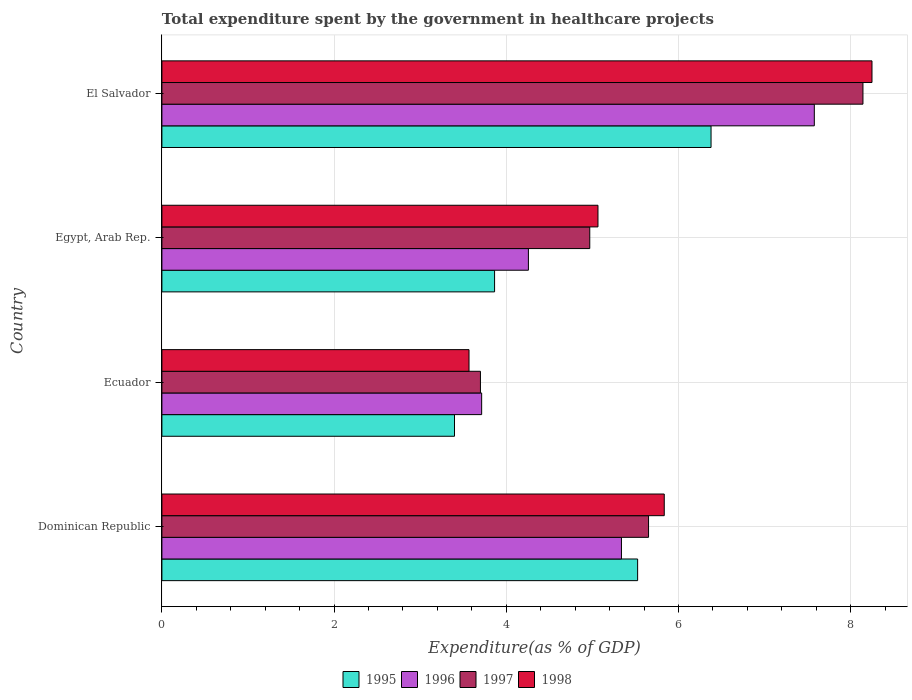How many bars are there on the 4th tick from the top?
Your answer should be very brief. 4. How many bars are there on the 4th tick from the bottom?
Ensure brevity in your answer.  4. What is the label of the 4th group of bars from the top?
Offer a very short reply. Dominican Republic. What is the total expenditure spent by the government in healthcare projects in 1995 in El Salvador?
Make the answer very short. 6.38. Across all countries, what is the maximum total expenditure spent by the government in healthcare projects in 1998?
Make the answer very short. 8.25. Across all countries, what is the minimum total expenditure spent by the government in healthcare projects in 1995?
Provide a succinct answer. 3.4. In which country was the total expenditure spent by the government in healthcare projects in 1998 maximum?
Your response must be concise. El Salvador. In which country was the total expenditure spent by the government in healthcare projects in 1998 minimum?
Ensure brevity in your answer.  Ecuador. What is the total total expenditure spent by the government in healthcare projects in 1997 in the graph?
Provide a succinct answer. 22.47. What is the difference between the total expenditure spent by the government in healthcare projects in 1995 in Dominican Republic and that in Egypt, Arab Rep.?
Offer a terse response. 1.66. What is the difference between the total expenditure spent by the government in healthcare projects in 1996 in Dominican Republic and the total expenditure spent by the government in healthcare projects in 1998 in El Salvador?
Ensure brevity in your answer.  -2.91. What is the average total expenditure spent by the government in healthcare projects in 1996 per country?
Provide a succinct answer. 5.22. What is the difference between the total expenditure spent by the government in healthcare projects in 1995 and total expenditure spent by the government in healthcare projects in 1996 in Ecuador?
Give a very brief answer. -0.32. In how many countries, is the total expenditure spent by the government in healthcare projects in 1995 greater than 0.8 %?
Ensure brevity in your answer.  4. What is the ratio of the total expenditure spent by the government in healthcare projects in 1996 in Dominican Republic to that in Ecuador?
Provide a short and direct response. 1.44. Is the difference between the total expenditure spent by the government in healthcare projects in 1995 in Egypt, Arab Rep. and El Salvador greater than the difference between the total expenditure spent by the government in healthcare projects in 1996 in Egypt, Arab Rep. and El Salvador?
Give a very brief answer. Yes. What is the difference between the highest and the second highest total expenditure spent by the government in healthcare projects in 1995?
Ensure brevity in your answer.  0.85. What is the difference between the highest and the lowest total expenditure spent by the government in healthcare projects in 1998?
Ensure brevity in your answer.  4.68. Is it the case that in every country, the sum of the total expenditure spent by the government in healthcare projects in 1996 and total expenditure spent by the government in healthcare projects in 1995 is greater than the sum of total expenditure spent by the government in healthcare projects in 1997 and total expenditure spent by the government in healthcare projects in 1998?
Keep it short and to the point. No. Is it the case that in every country, the sum of the total expenditure spent by the government in healthcare projects in 1996 and total expenditure spent by the government in healthcare projects in 1997 is greater than the total expenditure spent by the government in healthcare projects in 1995?
Give a very brief answer. Yes. How many bars are there?
Keep it short and to the point. 16. Are all the bars in the graph horizontal?
Make the answer very short. Yes. How many countries are there in the graph?
Keep it short and to the point. 4. Does the graph contain grids?
Provide a succinct answer. Yes. How are the legend labels stacked?
Ensure brevity in your answer.  Horizontal. What is the title of the graph?
Your answer should be very brief. Total expenditure spent by the government in healthcare projects. Does "1963" appear as one of the legend labels in the graph?
Keep it short and to the point. No. What is the label or title of the X-axis?
Your answer should be very brief. Expenditure(as % of GDP). What is the Expenditure(as % of GDP) of 1995 in Dominican Republic?
Your response must be concise. 5.53. What is the Expenditure(as % of GDP) in 1996 in Dominican Republic?
Offer a terse response. 5.34. What is the Expenditure(as % of GDP) in 1997 in Dominican Republic?
Your response must be concise. 5.65. What is the Expenditure(as % of GDP) of 1998 in Dominican Republic?
Make the answer very short. 5.84. What is the Expenditure(as % of GDP) in 1995 in Ecuador?
Give a very brief answer. 3.4. What is the Expenditure(as % of GDP) of 1996 in Ecuador?
Make the answer very short. 3.71. What is the Expenditure(as % of GDP) of 1997 in Ecuador?
Give a very brief answer. 3.7. What is the Expenditure(as % of GDP) in 1998 in Ecuador?
Provide a succinct answer. 3.57. What is the Expenditure(as % of GDP) in 1995 in Egypt, Arab Rep.?
Keep it short and to the point. 3.86. What is the Expenditure(as % of GDP) of 1996 in Egypt, Arab Rep.?
Provide a succinct answer. 4.26. What is the Expenditure(as % of GDP) of 1997 in Egypt, Arab Rep.?
Ensure brevity in your answer.  4.97. What is the Expenditure(as % of GDP) in 1998 in Egypt, Arab Rep.?
Your answer should be very brief. 5.07. What is the Expenditure(as % of GDP) of 1995 in El Salvador?
Your answer should be very brief. 6.38. What is the Expenditure(as % of GDP) of 1996 in El Salvador?
Provide a short and direct response. 7.58. What is the Expenditure(as % of GDP) of 1997 in El Salvador?
Give a very brief answer. 8.14. What is the Expenditure(as % of GDP) in 1998 in El Salvador?
Your response must be concise. 8.25. Across all countries, what is the maximum Expenditure(as % of GDP) in 1995?
Offer a terse response. 6.38. Across all countries, what is the maximum Expenditure(as % of GDP) of 1996?
Offer a very short reply. 7.58. Across all countries, what is the maximum Expenditure(as % of GDP) in 1997?
Make the answer very short. 8.14. Across all countries, what is the maximum Expenditure(as % of GDP) of 1998?
Offer a terse response. 8.25. Across all countries, what is the minimum Expenditure(as % of GDP) of 1995?
Provide a succinct answer. 3.4. Across all countries, what is the minimum Expenditure(as % of GDP) of 1996?
Provide a succinct answer. 3.71. Across all countries, what is the minimum Expenditure(as % of GDP) in 1997?
Your response must be concise. 3.7. Across all countries, what is the minimum Expenditure(as % of GDP) in 1998?
Make the answer very short. 3.57. What is the total Expenditure(as % of GDP) in 1995 in the graph?
Offer a terse response. 19.17. What is the total Expenditure(as % of GDP) in 1996 in the graph?
Ensure brevity in your answer.  20.89. What is the total Expenditure(as % of GDP) in 1997 in the graph?
Provide a short and direct response. 22.47. What is the total Expenditure(as % of GDP) in 1998 in the graph?
Offer a terse response. 22.72. What is the difference between the Expenditure(as % of GDP) in 1995 in Dominican Republic and that in Ecuador?
Your response must be concise. 2.13. What is the difference between the Expenditure(as % of GDP) of 1996 in Dominican Republic and that in Ecuador?
Provide a short and direct response. 1.62. What is the difference between the Expenditure(as % of GDP) of 1997 in Dominican Republic and that in Ecuador?
Your answer should be compact. 1.95. What is the difference between the Expenditure(as % of GDP) of 1998 in Dominican Republic and that in Ecuador?
Your answer should be compact. 2.27. What is the difference between the Expenditure(as % of GDP) in 1995 in Dominican Republic and that in Egypt, Arab Rep.?
Ensure brevity in your answer.  1.66. What is the difference between the Expenditure(as % of GDP) in 1996 in Dominican Republic and that in Egypt, Arab Rep.?
Make the answer very short. 1.08. What is the difference between the Expenditure(as % of GDP) of 1997 in Dominican Republic and that in Egypt, Arab Rep.?
Ensure brevity in your answer.  0.68. What is the difference between the Expenditure(as % of GDP) of 1998 in Dominican Republic and that in Egypt, Arab Rep.?
Your answer should be very brief. 0.77. What is the difference between the Expenditure(as % of GDP) in 1995 in Dominican Republic and that in El Salvador?
Your response must be concise. -0.85. What is the difference between the Expenditure(as % of GDP) in 1996 in Dominican Republic and that in El Salvador?
Your answer should be compact. -2.24. What is the difference between the Expenditure(as % of GDP) in 1997 in Dominican Republic and that in El Salvador?
Provide a short and direct response. -2.49. What is the difference between the Expenditure(as % of GDP) of 1998 in Dominican Republic and that in El Salvador?
Offer a terse response. -2.41. What is the difference between the Expenditure(as % of GDP) of 1995 in Ecuador and that in Egypt, Arab Rep.?
Provide a short and direct response. -0.47. What is the difference between the Expenditure(as % of GDP) in 1996 in Ecuador and that in Egypt, Arab Rep.?
Your answer should be very brief. -0.54. What is the difference between the Expenditure(as % of GDP) of 1997 in Ecuador and that in Egypt, Arab Rep.?
Your answer should be compact. -1.27. What is the difference between the Expenditure(as % of GDP) in 1998 in Ecuador and that in Egypt, Arab Rep.?
Provide a succinct answer. -1.5. What is the difference between the Expenditure(as % of GDP) in 1995 in Ecuador and that in El Salvador?
Make the answer very short. -2.98. What is the difference between the Expenditure(as % of GDP) in 1996 in Ecuador and that in El Salvador?
Keep it short and to the point. -3.86. What is the difference between the Expenditure(as % of GDP) of 1997 in Ecuador and that in El Salvador?
Give a very brief answer. -4.44. What is the difference between the Expenditure(as % of GDP) of 1998 in Ecuador and that in El Salvador?
Provide a succinct answer. -4.68. What is the difference between the Expenditure(as % of GDP) in 1995 in Egypt, Arab Rep. and that in El Salvador?
Your answer should be very brief. -2.51. What is the difference between the Expenditure(as % of GDP) of 1996 in Egypt, Arab Rep. and that in El Salvador?
Offer a very short reply. -3.32. What is the difference between the Expenditure(as % of GDP) in 1997 in Egypt, Arab Rep. and that in El Salvador?
Your answer should be very brief. -3.17. What is the difference between the Expenditure(as % of GDP) in 1998 in Egypt, Arab Rep. and that in El Salvador?
Give a very brief answer. -3.18. What is the difference between the Expenditure(as % of GDP) in 1995 in Dominican Republic and the Expenditure(as % of GDP) in 1996 in Ecuador?
Ensure brevity in your answer.  1.81. What is the difference between the Expenditure(as % of GDP) of 1995 in Dominican Republic and the Expenditure(as % of GDP) of 1997 in Ecuador?
Your answer should be compact. 1.83. What is the difference between the Expenditure(as % of GDP) of 1995 in Dominican Republic and the Expenditure(as % of GDP) of 1998 in Ecuador?
Your answer should be compact. 1.96. What is the difference between the Expenditure(as % of GDP) of 1996 in Dominican Republic and the Expenditure(as % of GDP) of 1997 in Ecuador?
Keep it short and to the point. 1.64. What is the difference between the Expenditure(as % of GDP) in 1996 in Dominican Republic and the Expenditure(as % of GDP) in 1998 in Ecuador?
Offer a very short reply. 1.77. What is the difference between the Expenditure(as % of GDP) in 1997 in Dominican Republic and the Expenditure(as % of GDP) in 1998 in Ecuador?
Ensure brevity in your answer.  2.09. What is the difference between the Expenditure(as % of GDP) of 1995 in Dominican Republic and the Expenditure(as % of GDP) of 1996 in Egypt, Arab Rep.?
Make the answer very short. 1.27. What is the difference between the Expenditure(as % of GDP) in 1995 in Dominican Republic and the Expenditure(as % of GDP) in 1997 in Egypt, Arab Rep.?
Provide a succinct answer. 0.56. What is the difference between the Expenditure(as % of GDP) in 1995 in Dominican Republic and the Expenditure(as % of GDP) in 1998 in Egypt, Arab Rep.?
Ensure brevity in your answer.  0.46. What is the difference between the Expenditure(as % of GDP) in 1996 in Dominican Republic and the Expenditure(as % of GDP) in 1997 in Egypt, Arab Rep.?
Make the answer very short. 0.37. What is the difference between the Expenditure(as % of GDP) in 1996 in Dominican Republic and the Expenditure(as % of GDP) in 1998 in Egypt, Arab Rep.?
Provide a succinct answer. 0.27. What is the difference between the Expenditure(as % of GDP) in 1997 in Dominican Republic and the Expenditure(as % of GDP) in 1998 in Egypt, Arab Rep.?
Your answer should be compact. 0.59. What is the difference between the Expenditure(as % of GDP) of 1995 in Dominican Republic and the Expenditure(as % of GDP) of 1996 in El Salvador?
Keep it short and to the point. -2.05. What is the difference between the Expenditure(as % of GDP) in 1995 in Dominican Republic and the Expenditure(as % of GDP) in 1997 in El Salvador?
Your response must be concise. -2.62. What is the difference between the Expenditure(as % of GDP) in 1995 in Dominican Republic and the Expenditure(as % of GDP) in 1998 in El Salvador?
Your answer should be very brief. -2.72. What is the difference between the Expenditure(as % of GDP) in 1996 in Dominican Republic and the Expenditure(as % of GDP) in 1997 in El Salvador?
Make the answer very short. -2.81. What is the difference between the Expenditure(as % of GDP) of 1996 in Dominican Republic and the Expenditure(as % of GDP) of 1998 in El Salvador?
Your response must be concise. -2.91. What is the difference between the Expenditure(as % of GDP) in 1997 in Dominican Republic and the Expenditure(as % of GDP) in 1998 in El Salvador?
Ensure brevity in your answer.  -2.6. What is the difference between the Expenditure(as % of GDP) in 1995 in Ecuador and the Expenditure(as % of GDP) in 1996 in Egypt, Arab Rep.?
Keep it short and to the point. -0.86. What is the difference between the Expenditure(as % of GDP) of 1995 in Ecuador and the Expenditure(as % of GDP) of 1997 in Egypt, Arab Rep.?
Your answer should be compact. -1.57. What is the difference between the Expenditure(as % of GDP) of 1995 in Ecuador and the Expenditure(as % of GDP) of 1998 in Egypt, Arab Rep.?
Offer a very short reply. -1.67. What is the difference between the Expenditure(as % of GDP) in 1996 in Ecuador and the Expenditure(as % of GDP) in 1997 in Egypt, Arab Rep.?
Make the answer very short. -1.26. What is the difference between the Expenditure(as % of GDP) in 1996 in Ecuador and the Expenditure(as % of GDP) in 1998 in Egypt, Arab Rep.?
Give a very brief answer. -1.35. What is the difference between the Expenditure(as % of GDP) in 1997 in Ecuador and the Expenditure(as % of GDP) in 1998 in Egypt, Arab Rep.?
Keep it short and to the point. -1.37. What is the difference between the Expenditure(as % of GDP) of 1995 in Ecuador and the Expenditure(as % of GDP) of 1996 in El Salvador?
Your answer should be compact. -4.18. What is the difference between the Expenditure(as % of GDP) in 1995 in Ecuador and the Expenditure(as % of GDP) in 1997 in El Salvador?
Your answer should be very brief. -4.74. What is the difference between the Expenditure(as % of GDP) in 1995 in Ecuador and the Expenditure(as % of GDP) in 1998 in El Salvador?
Offer a terse response. -4.85. What is the difference between the Expenditure(as % of GDP) in 1996 in Ecuador and the Expenditure(as % of GDP) in 1997 in El Salvador?
Your response must be concise. -4.43. What is the difference between the Expenditure(as % of GDP) of 1996 in Ecuador and the Expenditure(as % of GDP) of 1998 in El Salvador?
Give a very brief answer. -4.53. What is the difference between the Expenditure(as % of GDP) of 1997 in Ecuador and the Expenditure(as % of GDP) of 1998 in El Salvador?
Your answer should be very brief. -4.55. What is the difference between the Expenditure(as % of GDP) in 1995 in Egypt, Arab Rep. and the Expenditure(as % of GDP) in 1996 in El Salvador?
Provide a short and direct response. -3.71. What is the difference between the Expenditure(as % of GDP) in 1995 in Egypt, Arab Rep. and the Expenditure(as % of GDP) in 1997 in El Salvador?
Offer a very short reply. -4.28. What is the difference between the Expenditure(as % of GDP) in 1995 in Egypt, Arab Rep. and the Expenditure(as % of GDP) in 1998 in El Salvador?
Provide a succinct answer. -4.38. What is the difference between the Expenditure(as % of GDP) in 1996 in Egypt, Arab Rep. and the Expenditure(as % of GDP) in 1997 in El Salvador?
Provide a short and direct response. -3.89. What is the difference between the Expenditure(as % of GDP) of 1996 in Egypt, Arab Rep. and the Expenditure(as % of GDP) of 1998 in El Salvador?
Provide a short and direct response. -3.99. What is the difference between the Expenditure(as % of GDP) of 1997 in Egypt, Arab Rep. and the Expenditure(as % of GDP) of 1998 in El Salvador?
Offer a terse response. -3.28. What is the average Expenditure(as % of GDP) in 1995 per country?
Your response must be concise. 4.79. What is the average Expenditure(as % of GDP) in 1996 per country?
Provide a succinct answer. 5.22. What is the average Expenditure(as % of GDP) in 1997 per country?
Keep it short and to the point. 5.62. What is the average Expenditure(as % of GDP) in 1998 per country?
Give a very brief answer. 5.68. What is the difference between the Expenditure(as % of GDP) in 1995 and Expenditure(as % of GDP) in 1996 in Dominican Republic?
Give a very brief answer. 0.19. What is the difference between the Expenditure(as % of GDP) of 1995 and Expenditure(as % of GDP) of 1997 in Dominican Republic?
Provide a succinct answer. -0.13. What is the difference between the Expenditure(as % of GDP) in 1995 and Expenditure(as % of GDP) in 1998 in Dominican Republic?
Provide a short and direct response. -0.31. What is the difference between the Expenditure(as % of GDP) in 1996 and Expenditure(as % of GDP) in 1997 in Dominican Republic?
Offer a very short reply. -0.31. What is the difference between the Expenditure(as % of GDP) of 1996 and Expenditure(as % of GDP) of 1998 in Dominican Republic?
Provide a short and direct response. -0.5. What is the difference between the Expenditure(as % of GDP) in 1997 and Expenditure(as % of GDP) in 1998 in Dominican Republic?
Make the answer very short. -0.18. What is the difference between the Expenditure(as % of GDP) in 1995 and Expenditure(as % of GDP) in 1996 in Ecuador?
Your response must be concise. -0.32. What is the difference between the Expenditure(as % of GDP) of 1995 and Expenditure(as % of GDP) of 1997 in Ecuador?
Offer a terse response. -0.3. What is the difference between the Expenditure(as % of GDP) of 1995 and Expenditure(as % of GDP) of 1998 in Ecuador?
Give a very brief answer. -0.17. What is the difference between the Expenditure(as % of GDP) of 1996 and Expenditure(as % of GDP) of 1997 in Ecuador?
Give a very brief answer. 0.01. What is the difference between the Expenditure(as % of GDP) of 1996 and Expenditure(as % of GDP) of 1998 in Ecuador?
Offer a very short reply. 0.15. What is the difference between the Expenditure(as % of GDP) of 1997 and Expenditure(as % of GDP) of 1998 in Ecuador?
Your answer should be very brief. 0.13. What is the difference between the Expenditure(as % of GDP) in 1995 and Expenditure(as % of GDP) in 1996 in Egypt, Arab Rep.?
Ensure brevity in your answer.  -0.39. What is the difference between the Expenditure(as % of GDP) of 1995 and Expenditure(as % of GDP) of 1997 in Egypt, Arab Rep.?
Provide a succinct answer. -1.11. What is the difference between the Expenditure(as % of GDP) in 1995 and Expenditure(as % of GDP) in 1998 in Egypt, Arab Rep.?
Make the answer very short. -1.2. What is the difference between the Expenditure(as % of GDP) in 1996 and Expenditure(as % of GDP) in 1997 in Egypt, Arab Rep.?
Your answer should be very brief. -0.71. What is the difference between the Expenditure(as % of GDP) in 1996 and Expenditure(as % of GDP) in 1998 in Egypt, Arab Rep.?
Offer a very short reply. -0.81. What is the difference between the Expenditure(as % of GDP) of 1997 and Expenditure(as % of GDP) of 1998 in Egypt, Arab Rep.?
Ensure brevity in your answer.  -0.1. What is the difference between the Expenditure(as % of GDP) of 1995 and Expenditure(as % of GDP) of 1996 in El Salvador?
Make the answer very short. -1.2. What is the difference between the Expenditure(as % of GDP) of 1995 and Expenditure(as % of GDP) of 1997 in El Salvador?
Your answer should be compact. -1.76. What is the difference between the Expenditure(as % of GDP) in 1995 and Expenditure(as % of GDP) in 1998 in El Salvador?
Your answer should be very brief. -1.87. What is the difference between the Expenditure(as % of GDP) of 1996 and Expenditure(as % of GDP) of 1997 in El Salvador?
Ensure brevity in your answer.  -0.56. What is the difference between the Expenditure(as % of GDP) in 1996 and Expenditure(as % of GDP) in 1998 in El Salvador?
Your response must be concise. -0.67. What is the difference between the Expenditure(as % of GDP) of 1997 and Expenditure(as % of GDP) of 1998 in El Salvador?
Offer a very short reply. -0.1. What is the ratio of the Expenditure(as % of GDP) of 1995 in Dominican Republic to that in Ecuador?
Give a very brief answer. 1.63. What is the ratio of the Expenditure(as % of GDP) in 1996 in Dominican Republic to that in Ecuador?
Offer a very short reply. 1.44. What is the ratio of the Expenditure(as % of GDP) of 1997 in Dominican Republic to that in Ecuador?
Offer a terse response. 1.53. What is the ratio of the Expenditure(as % of GDP) of 1998 in Dominican Republic to that in Ecuador?
Your answer should be very brief. 1.64. What is the ratio of the Expenditure(as % of GDP) in 1995 in Dominican Republic to that in Egypt, Arab Rep.?
Offer a terse response. 1.43. What is the ratio of the Expenditure(as % of GDP) of 1996 in Dominican Republic to that in Egypt, Arab Rep.?
Offer a very short reply. 1.25. What is the ratio of the Expenditure(as % of GDP) of 1997 in Dominican Republic to that in Egypt, Arab Rep.?
Offer a terse response. 1.14. What is the ratio of the Expenditure(as % of GDP) of 1998 in Dominican Republic to that in Egypt, Arab Rep.?
Your answer should be very brief. 1.15. What is the ratio of the Expenditure(as % of GDP) in 1995 in Dominican Republic to that in El Salvador?
Your response must be concise. 0.87. What is the ratio of the Expenditure(as % of GDP) of 1996 in Dominican Republic to that in El Salvador?
Your answer should be very brief. 0.7. What is the ratio of the Expenditure(as % of GDP) of 1997 in Dominican Republic to that in El Salvador?
Your answer should be very brief. 0.69. What is the ratio of the Expenditure(as % of GDP) in 1998 in Dominican Republic to that in El Salvador?
Your answer should be compact. 0.71. What is the ratio of the Expenditure(as % of GDP) in 1995 in Ecuador to that in Egypt, Arab Rep.?
Make the answer very short. 0.88. What is the ratio of the Expenditure(as % of GDP) in 1996 in Ecuador to that in Egypt, Arab Rep.?
Ensure brevity in your answer.  0.87. What is the ratio of the Expenditure(as % of GDP) of 1997 in Ecuador to that in Egypt, Arab Rep.?
Give a very brief answer. 0.74. What is the ratio of the Expenditure(as % of GDP) of 1998 in Ecuador to that in Egypt, Arab Rep.?
Offer a very short reply. 0.7. What is the ratio of the Expenditure(as % of GDP) in 1995 in Ecuador to that in El Salvador?
Offer a terse response. 0.53. What is the ratio of the Expenditure(as % of GDP) of 1996 in Ecuador to that in El Salvador?
Offer a very short reply. 0.49. What is the ratio of the Expenditure(as % of GDP) of 1997 in Ecuador to that in El Salvador?
Offer a terse response. 0.45. What is the ratio of the Expenditure(as % of GDP) in 1998 in Ecuador to that in El Salvador?
Offer a terse response. 0.43. What is the ratio of the Expenditure(as % of GDP) in 1995 in Egypt, Arab Rep. to that in El Salvador?
Provide a succinct answer. 0.61. What is the ratio of the Expenditure(as % of GDP) in 1996 in Egypt, Arab Rep. to that in El Salvador?
Your answer should be very brief. 0.56. What is the ratio of the Expenditure(as % of GDP) in 1997 in Egypt, Arab Rep. to that in El Salvador?
Offer a terse response. 0.61. What is the ratio of the Expenditure(as % of GDP) of 1998 in Egypt, Arab Rep. to that in El Salvador?
Ensure brevity in your answer.  0.61. What is the difference between the highest and the second highest Expenditure(as % of GDP) in 1995?
Make the answer very short. 0.85. What is the difference between the highest and the second highest Expenditure(as % of GDP) of 1996?
Give a very brief answer. 2.24. What is the difference between the highest and the second highest Expenditure(as % of GDP) in 1997?
Give a very brief answer. 2.49. What is the difference between the highest and the second highest Expenditure(as % of GDP) in 1998?
Keep it short and to the point. 2.41. What is the difference between the highest and the lowest Expenditure(as % of GDP) of 1995?
Your answer should be very brief. 2.98. What is the difference between the highest and the lowest Expenditure(as % of GDP) in 1996?
Offer a very short reply. 3.86. What is the difference between the highest and the lowest Expenditure(as % of GDP) in 1997?
Offer a terse response. 4.44. What is the difference between the highest and the lowest Expenditure(as % of GDP) of 1998?
Ensure brevity in your answer.  4.68. 